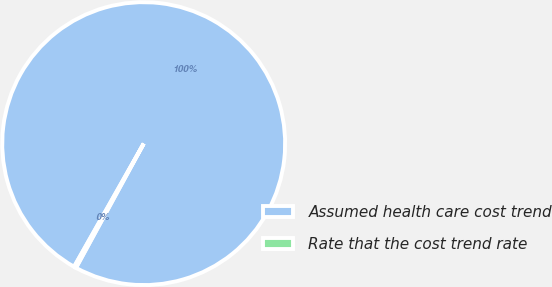Convert chart to OTSL. <chart><loc_0><loc_0><loc_500><loc_500><pie_chart><fcel>Assumed health care cost trend<fcel>Rate that the cost trend rate<nl><fcel>99.75%<fcel>0.25%<nl></chart> 